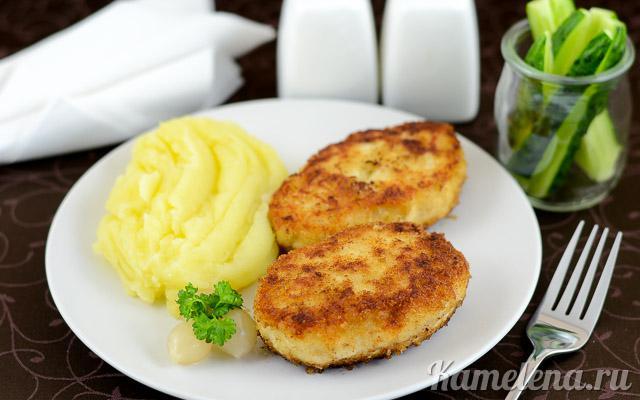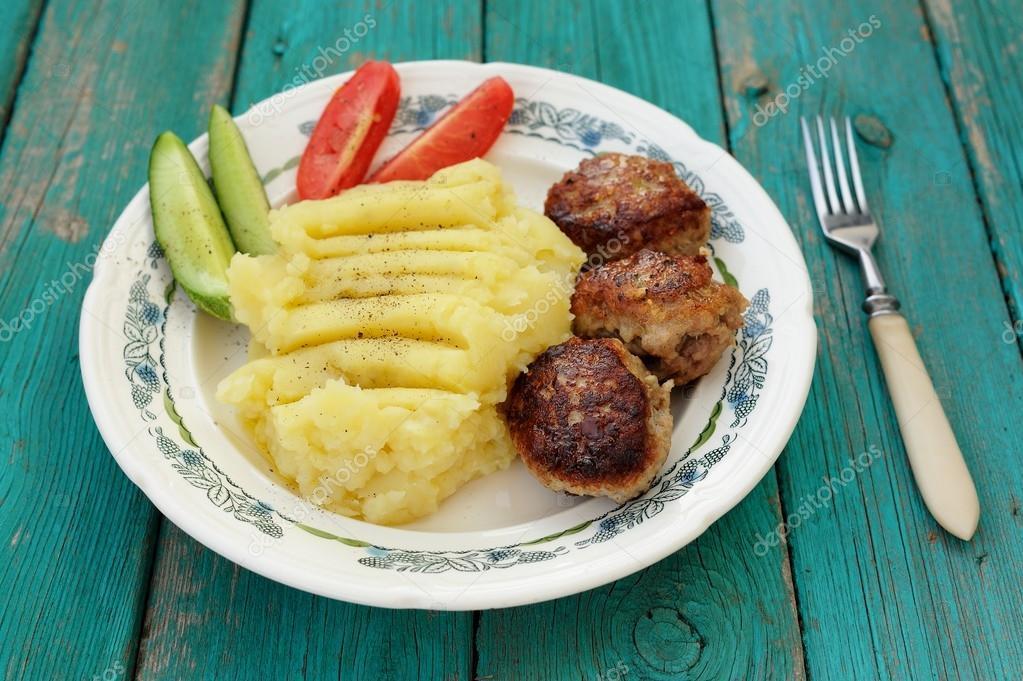The first image is the image on the left, the second image is the image on the right. Analyze the images presented: Is the assertion "A dish featuring mashed potatoes with gravy has a bright red rim." valid? Answer yes or no. No. The first image is the image on the left, the second image is the image on the right. Examine the images to the left and right. Is the description "In one image there is one or more utensils on the plate." accurate? Answer yes or no. No. 